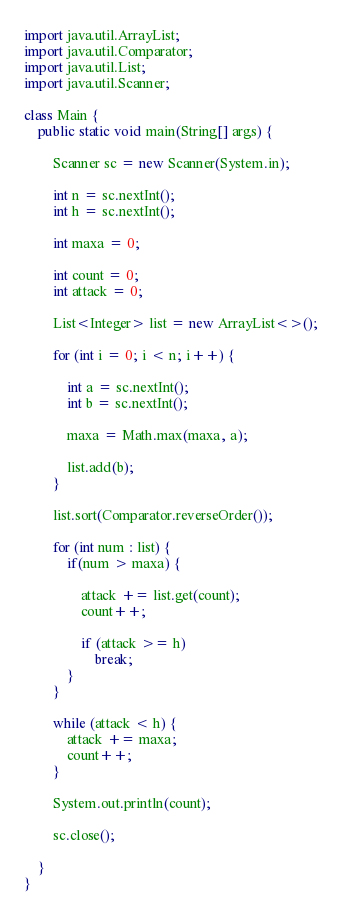<code> <loc_0><loc_0><loc_500><loc_500><_Java_>import java.util.ArrayList;
import java.util.Comparator;
import java.util.List;
import java.util.Scanner;

class Main {
	public static void main(String[] args) {

		Scanner sc = new Scanner(System.in);

		int n = sc.nextInt();
		int h = sc.nextInt();

		int maxa = 0;

		int count = 0;
		int attack = 0;

		List<Integer> list = new ArrayList<>();

		for (int i = 0; i < n; i++) {

			int a = sc.nextInt();
			int b = sc.nextInt();

			maxa = Math.max(maxa, a);

			list.add(b);
		}

		list.sort(Comparator.reverseOrder());

		for (int num : list) {
			if(num > maxa) {

				attack += list.get(count);
				count++;

				if (attack >= h)
					break;
			}
		}

		while (attack < h) {
			attack += maxa;
			count++;
		}

		System.out.println(count);

		sc.close();

	}
}</code> 